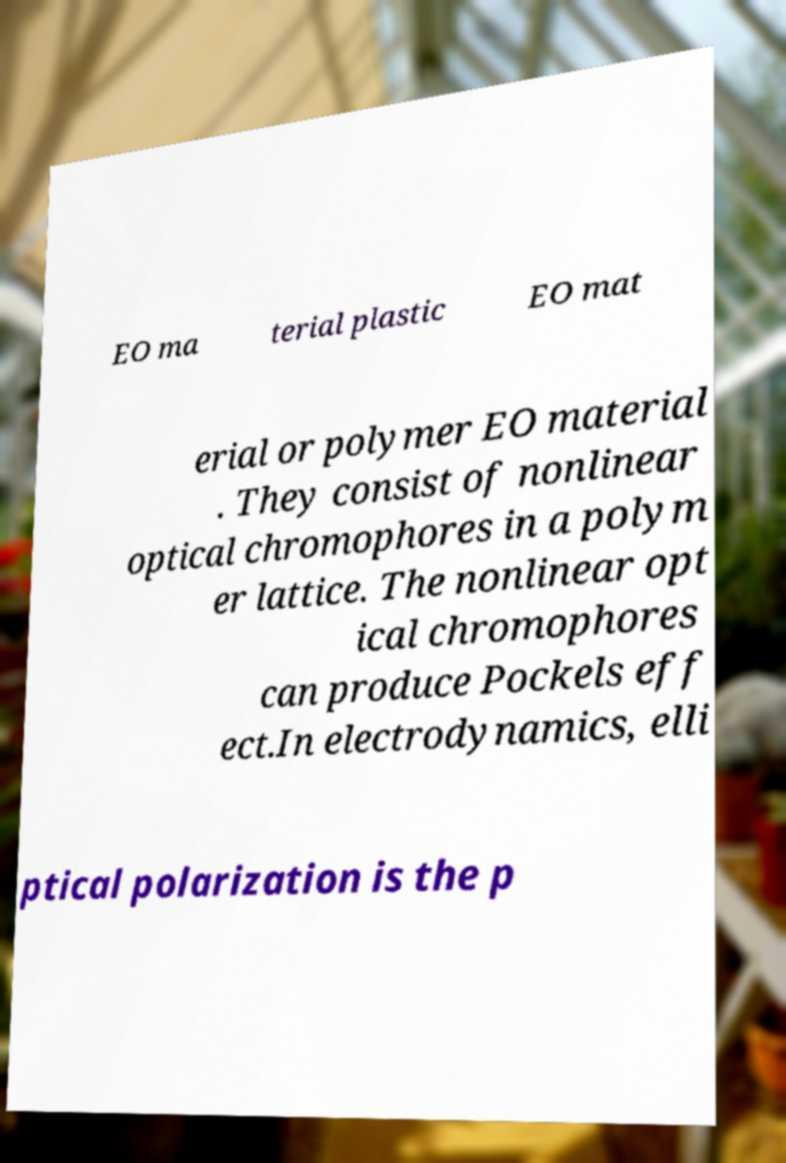Please read and relay the text visible in this image. What does it say? EO ma terial plastic EO mat erial or polymer EO material . They consist of nonlinear optical chromophores in a polym er lattice. The nonlinear opt ical chromophores can produce Pockels eff ect.In electrodynamics, elli ptical polarization is the p 